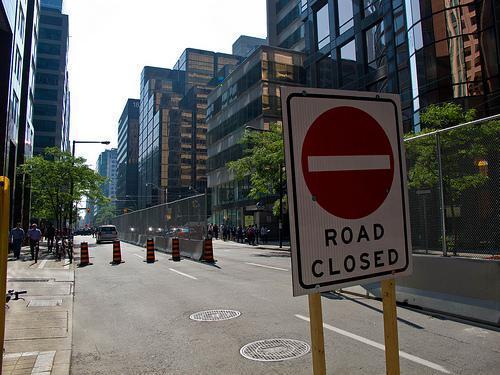How many vehicles are on the street?
Give a very brief answer. 1. 